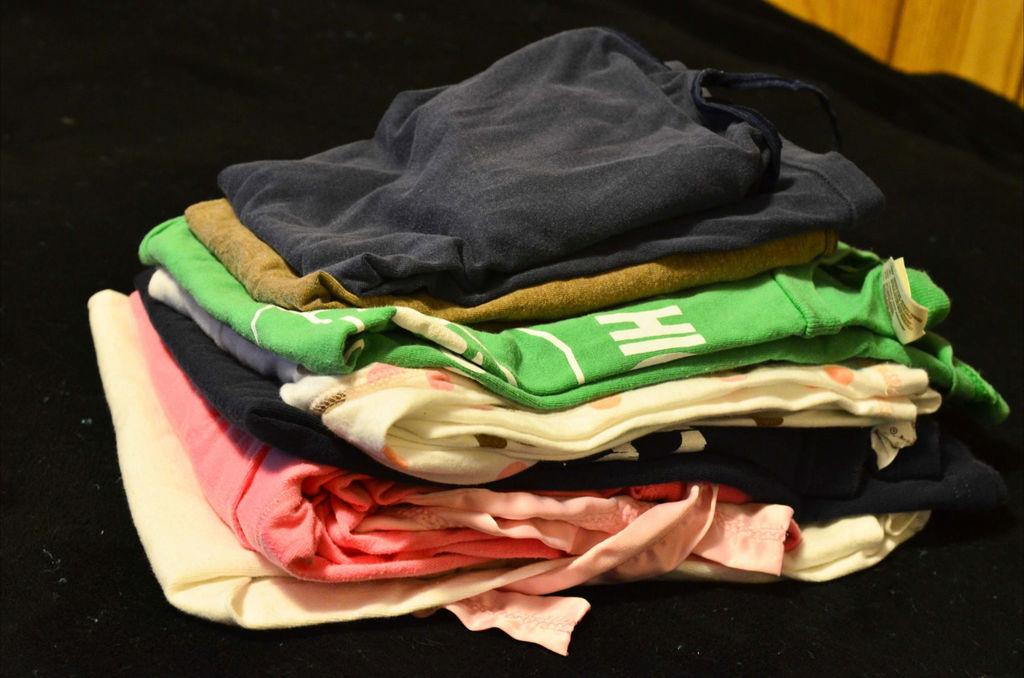What is present in the image related to personal attire? There are clothes in the image. Can you describe the arrangement of the clothes in the image? The clothes are on an object. What is the chance of winning a prize while wearing these clothes in the image? There is no information about winning a prize or any game in the image, so it's not possible to determine the chance of winning. 